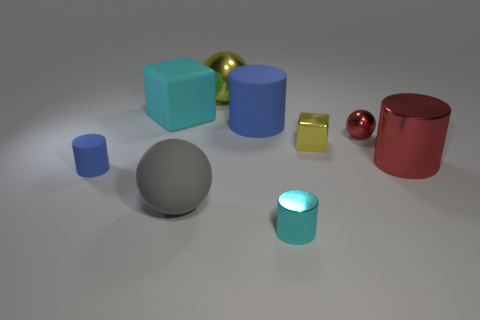What number of small shiny objects are behind the large metallic object in front of the small red sphere?
Offer a very short reply. 2. Are there any cyan blocks?
Provide a succinct answer. Yes. Are there any big yellow cylinders that have the same material as the tiny cyan object?
Your response must be concise. No. Is the number of small blue things on the right side of the big cyan rubber block greater than the number of small shiny cylinders on the right side of the cyan cylinder?
Give a very brief answer. No. Do the gray sphere and the red metal ball have the same size?
Your answer should be very brief. No. What is the color of the large thing that is in front of the red thing that is in front of the small ball?
Your answer should be very brief. Gray. The small sphere has what color?
Make the answer very short. Red. Are there any large shiny cylinders of the same color as the metal block?
Your answer should be compact. No. Is the color of the matte cylinder in front of the small yellow shiny thing the same as the big rubber cylinder?
Provide a succinct answer. Yes. How many things are tiny metallic things in front of the tiny red metal object or large red matte cylinders?
Your response must be concise. 2. 